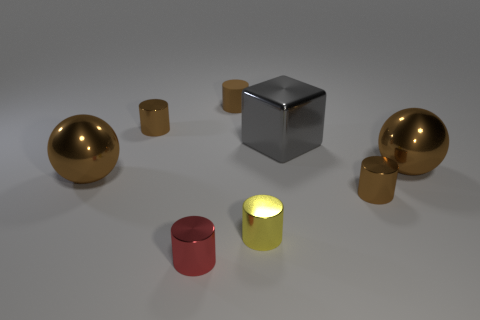There is a tiny metallic cylinder that is to the right of the yellow metallic object; what is its color?
Your response must be concise. Brown. Is the size of the brown metal cylinder on the right side of the small matte cylinder the same as the sphere that is left of the tiny yellow cylinder?
Offer a terse response. No. Are there any gray cubes of the same size as the red object?
Provide a short and direct response. No. There is a tiny cylinder that is to the right of the yellow thing; how many big spheres are in front of it?
Provide a short and direct response. 0. What is the gray cube made of?
Your answer should be compact. Metal. There is a brown rubber thing; how many small brown shiny objects are left of it?
Provide a short and direct response. 1. Does the cube have the same color as the rubber cylinder?
Make the answer very short. No. What number of metal cylinders are the same color as the small rubber cylinder?
Provide a succinct answer. 2. Are there more large brown things than big metal things?
Ensure brevity in your answer.  No. What is the size of the metal cylinder that is both in front of the large gray metal cube and behind the yellow metallic cylinder?
Provide a succinct answer. Small. 